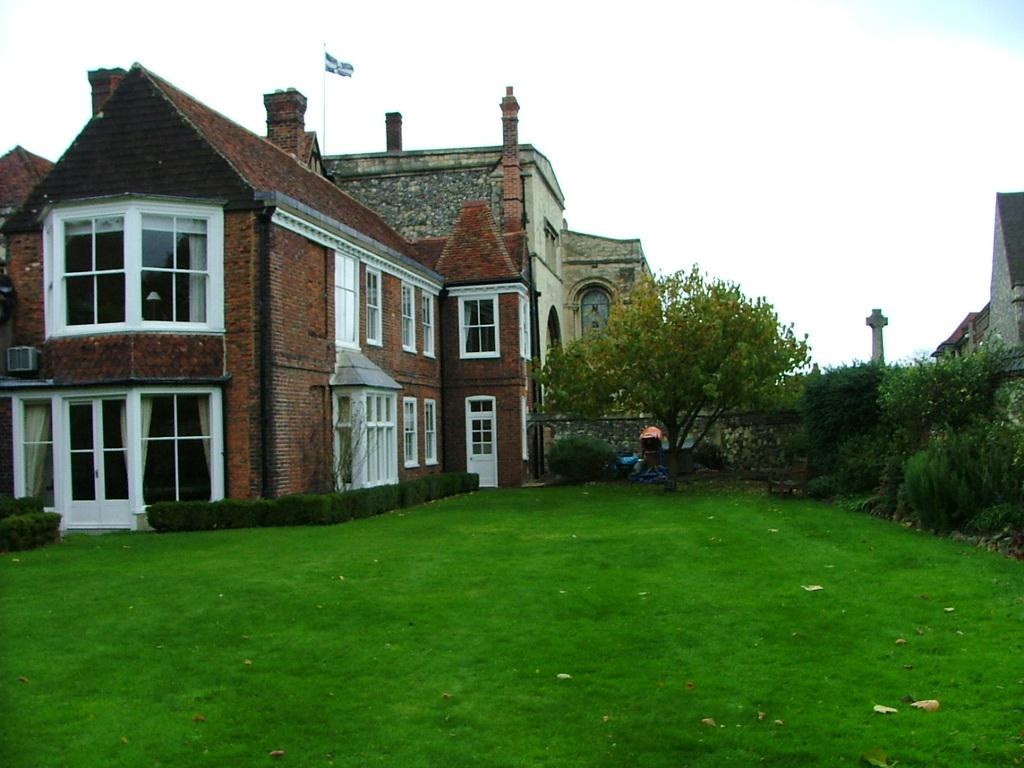What type of surface is visible in the image? There is a grass surface in the image. What other natural elements can be seen in the image? There are plants in the image. What type of structure is present in the image? There is a building with windows in the image. What is visible in the background of the image? The sky is visible in the image, and there are clouds in the sky. What type of coal is being used to fuel the pet in the image? There is no coal or pet present in the image. 